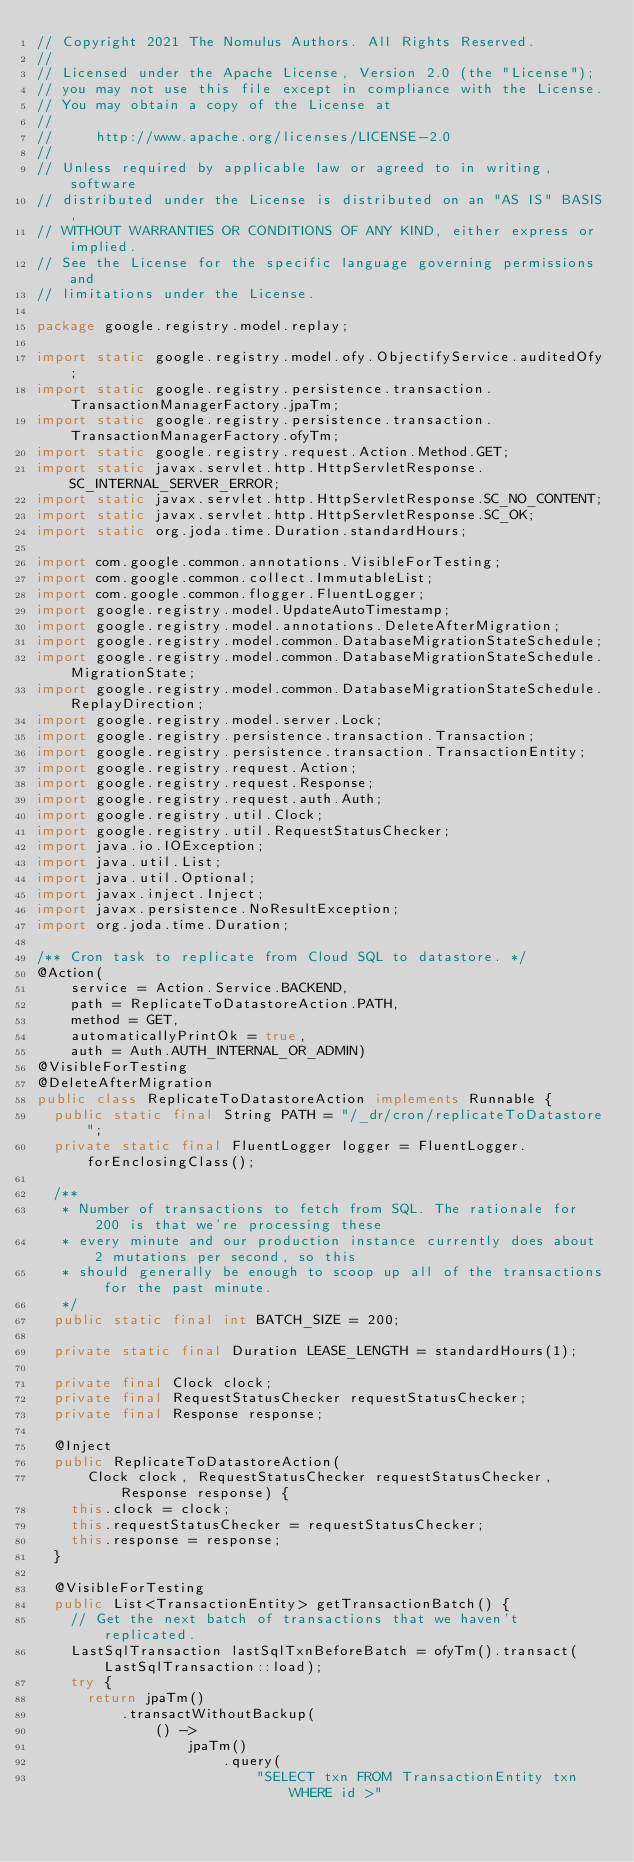<code> <loc_0><loc_0><loc_500><loc_500><_Java_>// Copyright 2021 The Nomulus Authors. All Rights Reserved.
//
// Licensed under the Apache License, Version 2.0 (the "License");
// you may not use this file except in compliance with the License.
// You may obtain a copy of the License at
//
//     http://www.apache.org/licenses/LICENSE-2.0
//
// Unless required by applicable law or agreed to in writing, software
// distributed under the License is distributed on an "AS IS" BASIS,
// WITHOUT WARRANTIES OR CONDITIONS OF ANY KIND, either express or implied.
// See the License for the specific language governing permissions and
// limitations under the License.

package google.registry.model.replay;

import static google.registry.model.ofy.ObjectifyService.auditedOfy;
import static google.registry.persistence.transaction.TransactionManagerFactory.jpaTm;
import static google.registry.persistence.transaction.TransactionManagerFactory.ofyTm;
import static google.registry.request.Action.Method.GET;
import static javax.servlet.http.HttpServletResponse.SC_INTERNAL_SERVER_ERROR;
import static javax.servlet.http.HttpServletResponse.SC_NO_CONTENT;
import static javax.servlet.http.HttpServletResponse.SC_OK;
import static org.joda.time.Duration.standardHours;

import com.google.common.annotations.VisibleForTesting;
import com.google.common.collect.ImmutableList;
import com.google.common.flogger.FluentLogger;
import google.registry.model.UpdateAutoTimestamp;
import google.registry.model.annotations.DeleteAfterMigration;
import google.registry.model.common.DatabaseMigrationStateSchedule;
import google.registry.model.common.DatabaseMigrationStateSchedule.MigrationState;
import google.registry.model.common.DatabaseMigrationStateSchedule.ReplayDirection;
import google.registry.model.server.Lock;
import google.registry.persistence.transaction.Transaction;
import google.registry.persistence.transaction.TransactionEntity;
import google.registry.request.Action;
import google.registry.request.Response;
import google.registry.request.auth.Auth;
import google.registry.util.Clock;
import google.registry.util.RequestStatusChecker;
import java.io.IOException;
import java.util.List;
import java.util.Optional;
import javax.inject.Inject;
import javax.persistence.NoResultException;
import org.joda.time.Duration;

/** Cron task to replicate from Cloud SQL to datastore. */
@Action(
    service = Action.Service.BACKEND,
    path = ReplicateToDatastoreAction.PATH,
    method = GET,
    automaticallyPrintOk = true,
    auth = Auth.AUTH_INTERNAL_OR_ADMIN)
@VisibleForTesting
@DeleteAfterMigration
public class ReplicateToDatastoreAction implements Runnable {
  public static final String PATH = "/_dr/cron/replicateToDatastore";
  private static final FluentLogger logger = FluentLogger.forEnclosingClass();

  /**
   * Number of transactions to fetch from SQL. The rationale for 200 is that we're processing these
   * every minute and our production instance currently does about 2 mutations per second, so this
   * should generally be enough to scoop up all of the transactions for the past minute.
   */
  public static final int BATCH_SIZE = 200;

  private static final Duration LEASE_LENGTH = standardHours(1);

  private final Clock clock;
  private final RequestStatusChecker requestStatusChecker;
  private final Response response;

  @Inject
  public ReplicateToDatastoreAction(
      Clock clock, RequestStatusChecker requestStatusChecker, Response response) {
    this.clock = clock;
    this.requestStatusChecker = requestStatusChecker;
    this.response = response;
  }

  @VisibleForTesting
  public List<TransactionEntity> getTransactionBatch() {
    // Get the next batch of transactions that we haven't replicated.
    LastSqlTransaction lastSqlTxnBeforeBatch = ofyTm().transact(LastSqlTransaction::load);
    try {
      return jpaTm()
          .transactWithoutBackup(
              () ->
                  jpaTm()
                      .query(
                          "SELECT txn FROM TransactionEntity txn WHERE id >"</code> 